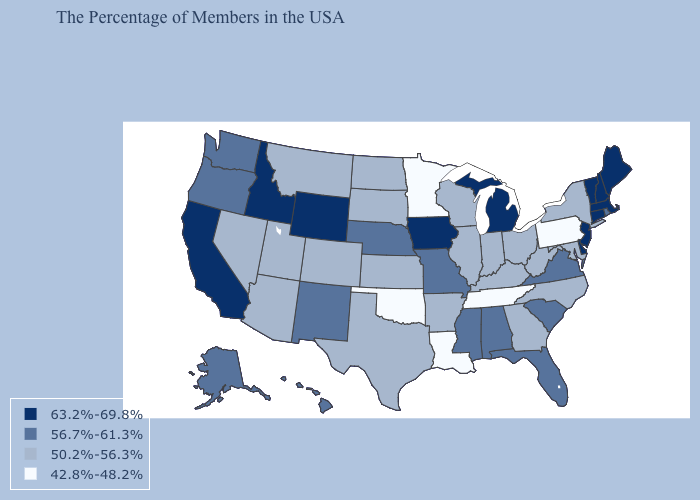Which states hav the highest value in the South?
Short answer required. Delaware. Does Nevada have a higher value than Pennsylvania?
Short answer required. Yes. Name the states that have a value in the range 42.8%-48.2%?
Concise answer only. Pennsylvania, Tennessee, Louisiana, Minnesota, Oklahoma. Does the first symbol in the legend represent the smallest category?
Be succinct. No. What is the lowest value in the Northeast?
Answer briefly. 42.8%-48.2%. What is the lowest value in the South?
Quick response, please. 42.8%-48.2%. Does Maryland have the same value as Alaska?
Short answer required. No. Among the states that border North Dakota , does Minnesota have the highest value?
Keep it brief. No. Name the states that have a value in the range 50.2%-56.3%?
Be succinct. New York, Maryland, North Carolina, West Virginia, Ohio, Georgia, Kentucky, Indiana, Wisconsin, Illinois, Arkansas, Kansas, Texas, South Dakota, North Dakota, Colorado, Utah, Montana, Arizona, Nevada. Does Alabama have a higher value than Mississippi?
Give a very brief answer. No. Does Montana have the highest value in the West?
Be succinct. No. What is the highest value in the USA?
Quick response, please. 63.2%-69.8%. What is the value of Michigan?
Write a very short answer. 63.2%-69.8%. Name the states that have a value in the range 42.8%-48.2%?
Be succinct. Pennsylvania, Tennessee, Louisiana, Minnesota, Oklahoma. Name the states that have a value in the range 42.8%-48.2%?
Answer briefly. Pennsylvania, Tennessee, Louisiana, Minnesota, Oklahoma. 